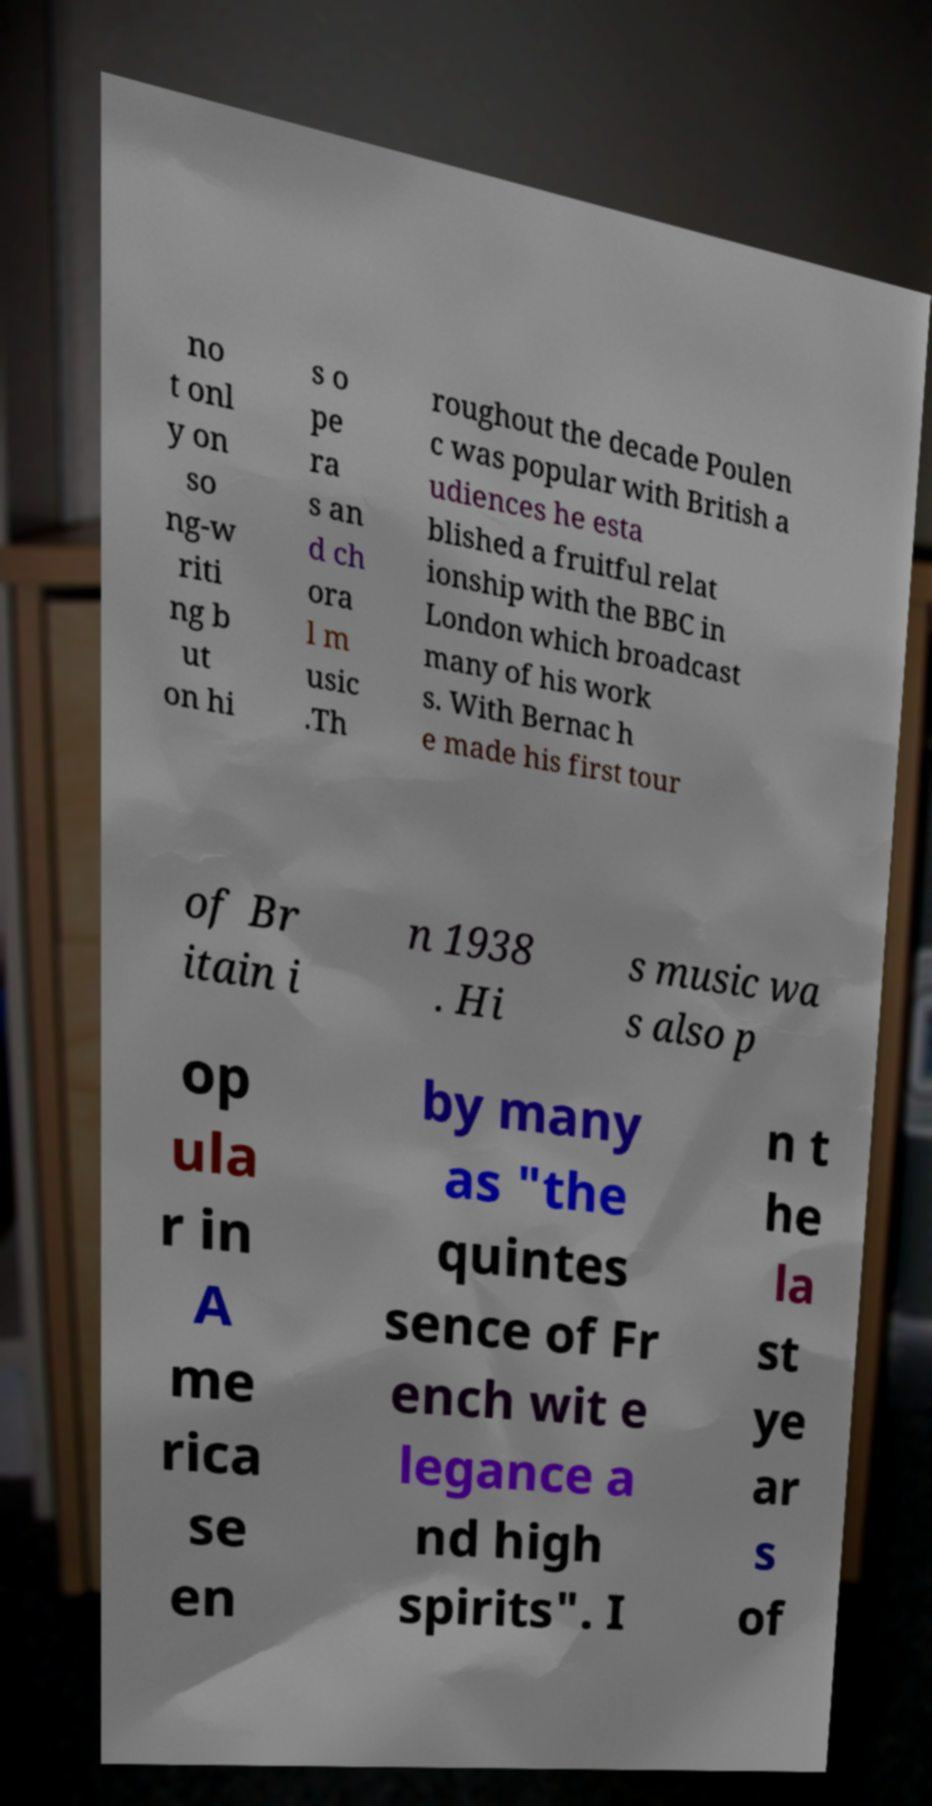There's text embedded in this image that I need extracted. Can you transcribe it verbatim? no t onl y on so ng-w riti ng b ut on hi s o pe ra s an d ch ora l m usic .Th roughout the decade Poulen c was popular with British a udiences he esta blished a fruitful relat ionship with the BBC in London which broadcast many of his work s. With Bernac h e made his first tour of Br itain i n 1938 . Hi s music wa s also p op ula r in A me rica se en by many as "the quintes sence of Fr ench wit e legance a nd high spirits". I n t he la st ye ar s of 